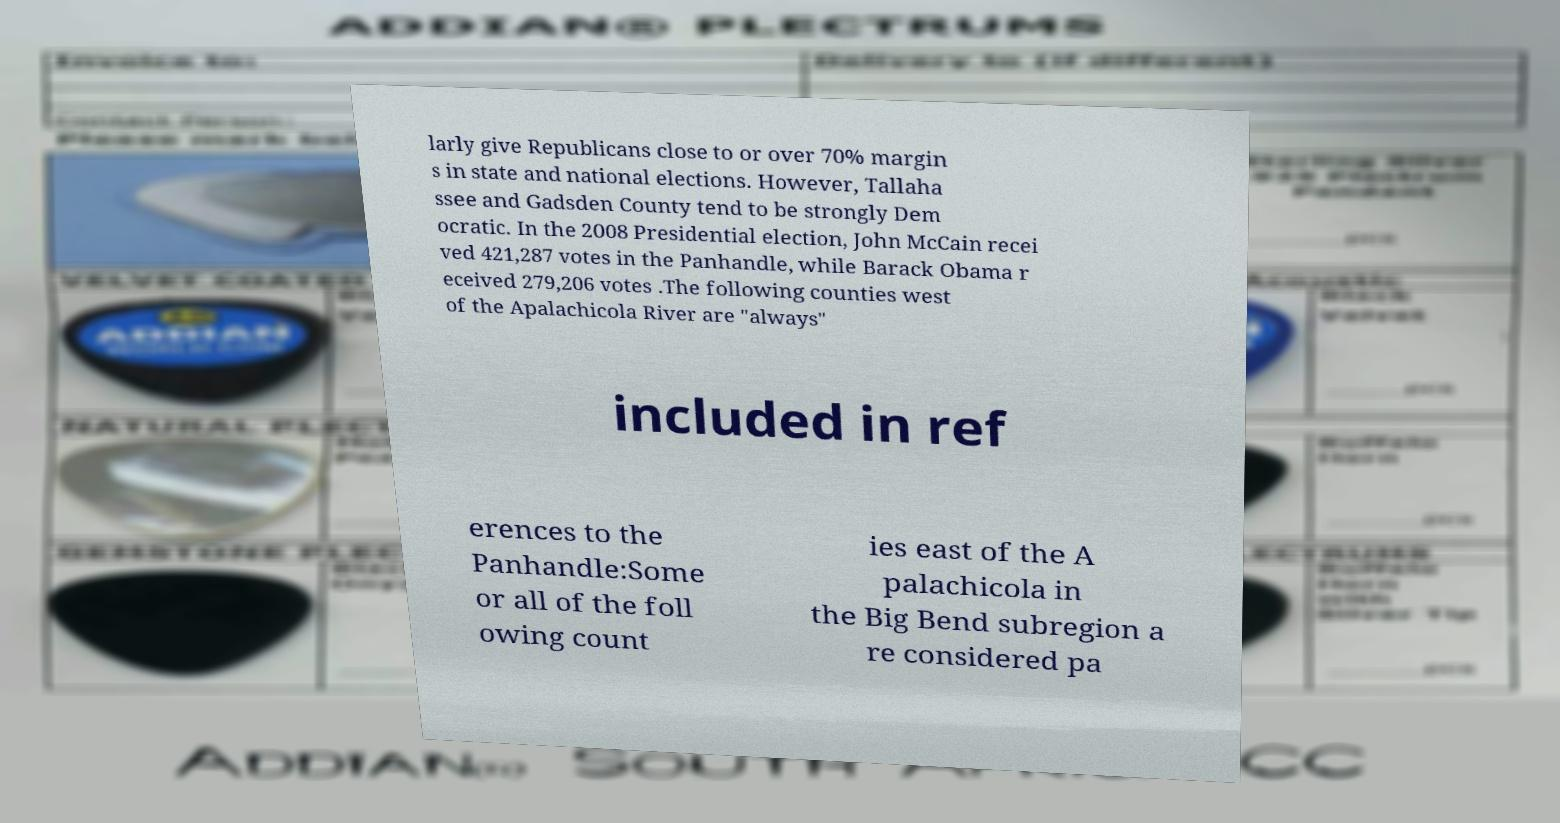Can you read and provide the text displayed in the image?This photo seems to have some interesting text. Can you extract and type it out for me? larly give Republicans close to or over 70% margin s in state and national elections. However, Tallaha ssee and Gadsden County tend to be strongly Dem ocratic. In the 2008 Presidential election, John McCain recei ved 421,287 votes in the Panhandle, while Barack Obama r eceived 279,206 votes .The following counties west of the Apalachicola River are "always" included in ref erences to the Panhandle:Some or all of the foll owing count ies east of the A palachicola in the Big Bend subregion a re considered pa 